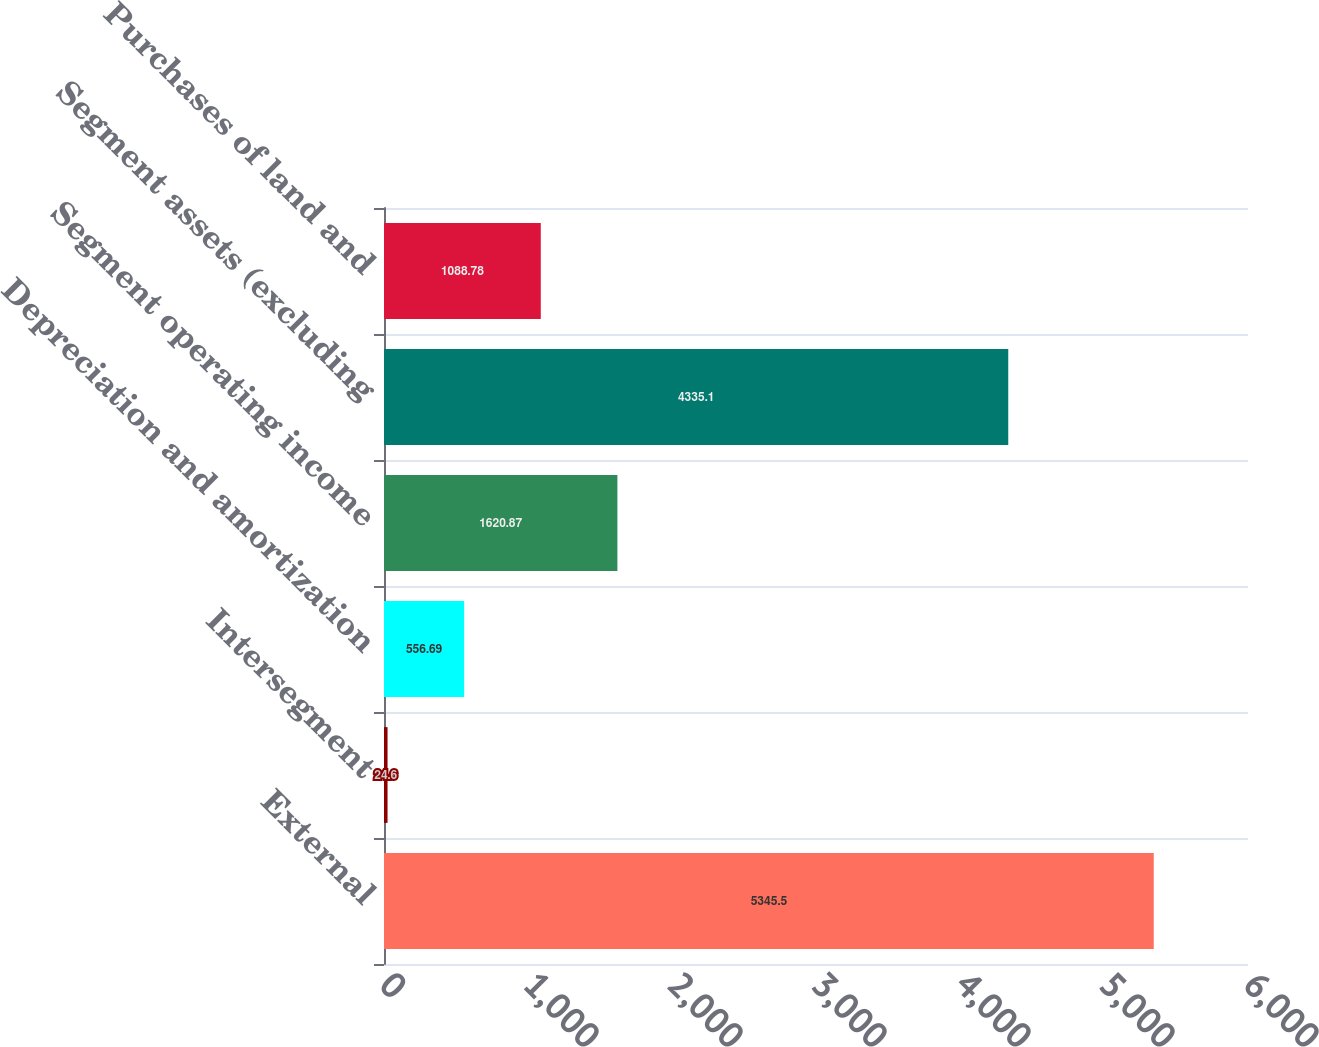Convert chart to OTSL. <chart><loc_0><loc_0><loc_500><loc_500><bar_chart><fcel>External<fcel>Intersegment<fcel>Depreciation and amortization<fcel>Segment operating income<fcel>Segment assets (excluding<fcel>Purchases of land and<nl><fcel>5345.5<fcel>24.6<fcel>556.69<fcel>1620.87<fcel>4335.1<fcel>1088.78<nl></chart> 